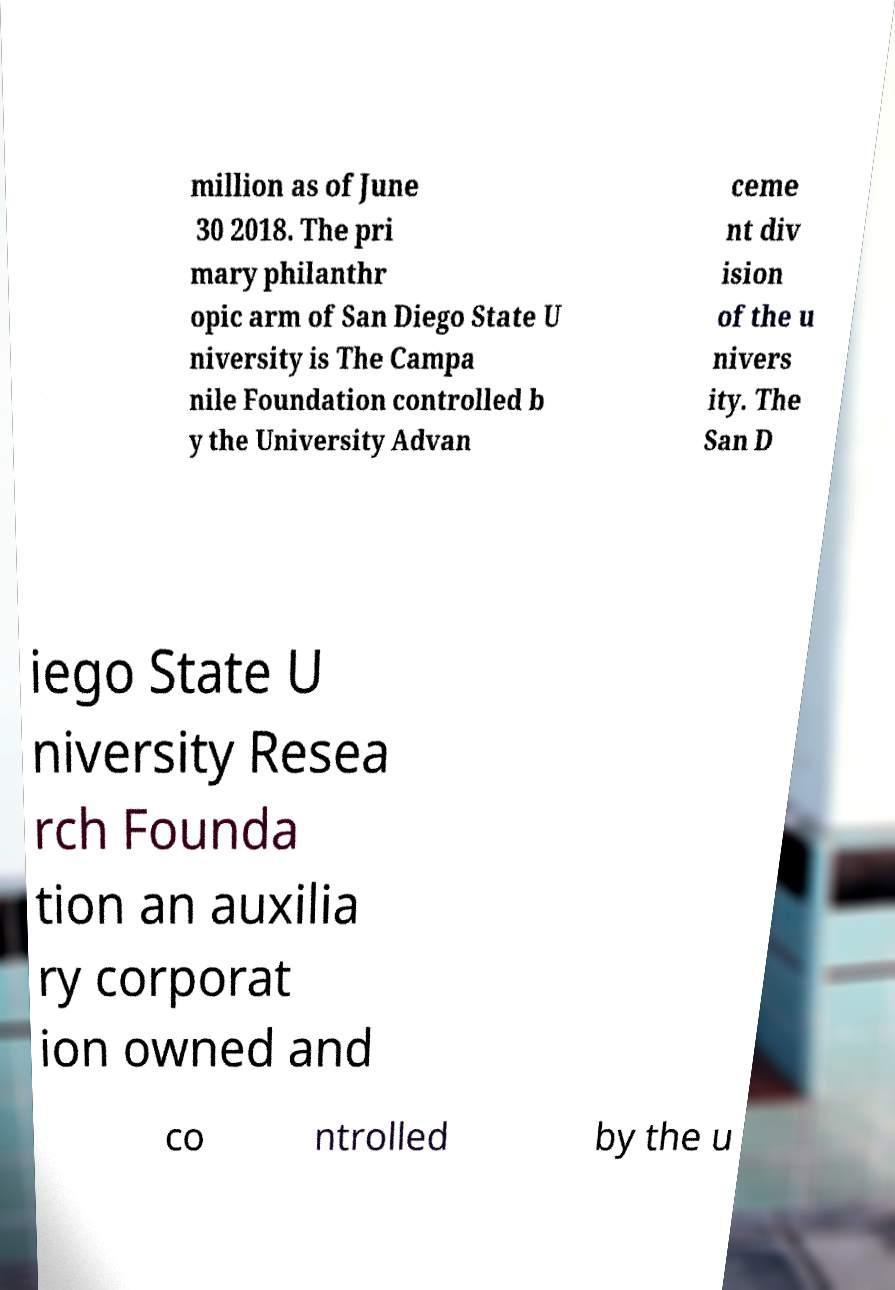Can you read and provide the text displayed in the image?This photo seems to have some interesting text. Can you extract and type it out for me? million as of June 30 2018. The pri mary philanthr opic arm of San Diego State U niversity is The Campa nile Foundation controlled b y the University Advan ceme nt div ision of the u nivers ity. The San D iego State U niversity Resea rch Founda tion an auxilia ry corporat ion owned and co ntrolled by the u 